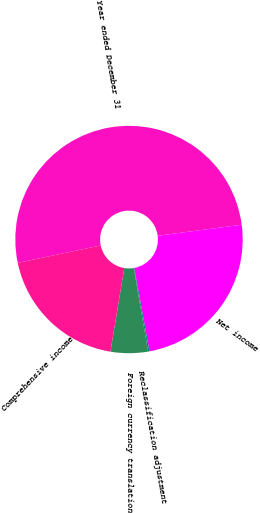Convert chart. <chart><loc_0><loc_0><loc_500><loc_500><pie_chart><fcel>Year ended December 31<fcel>Net income<fcel>Reclassification adjustment<fcel>Foreign currency translation<fcel>Comprehensive income<nl><fcel>51.21%<fcel>24.19%<fcel>0.2%<fcel>5.3%<fcel>19.09%<nl></chart> 